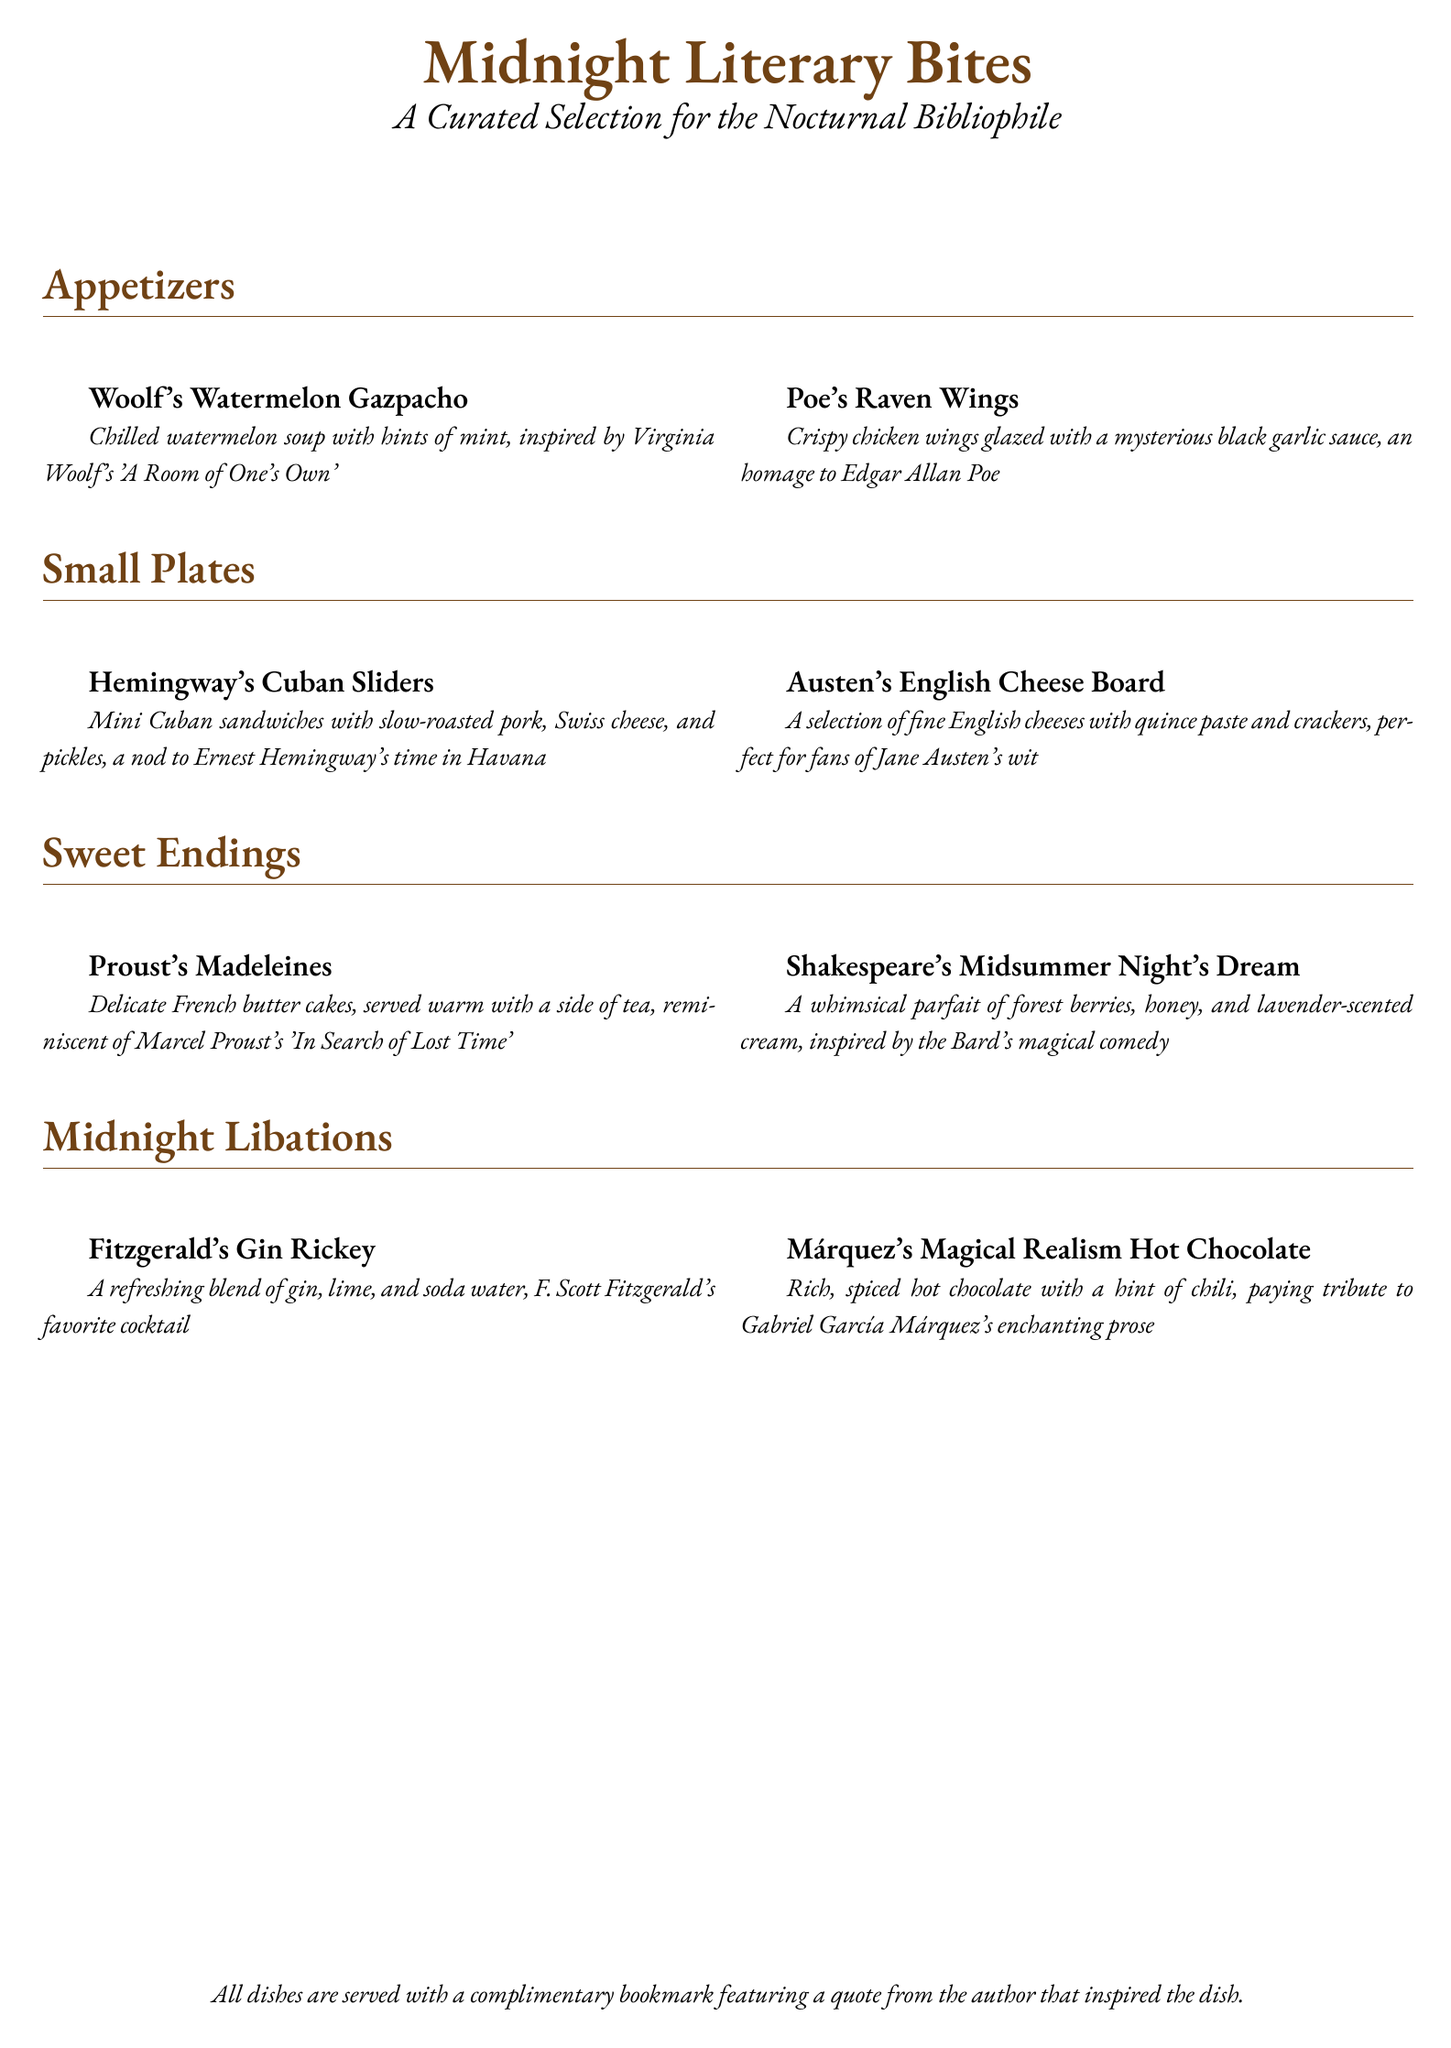What inspired Woolf's Watermelon Gazpacho? The gazpacho is inspired by Virginia Woolf's 'A Room of One's Own'.
Answer: 'A Room of One's Own' What dishes are included in the Sweet Endings section? The Sweet Endings section features Proust's Madeleines and Shakespeare's Midsummer Night's Dream.
Answer: Proust's Madeleines, Shakespeare's Midsummer Night's Dream Which author is associated with the drink Fitzgerald's Gin Rickey? The drink is associated with F. Scott Fitzgerald.
Answer: F. Scott Fitzgerald How many small plates are listed on the menu? There are two small plates listed on the menu: Hemingway's Cuban Sliders and Austen's English Cheese Board.
Answer: 2 What is served with all dishes? All dishes are served with a complimentary bookmark featuring a quote from the author that inspired the dish.
Answer: A complimentary bookmark What type of cuisine is Hemingway's Cuban Sliders? The sliders are a type of mini Cuban sandwiches.
Answer: Mini Cuban sandwiches Which dish pays tribute to Gabriel García Márquez? Márquez's Magical Realism Hot Chocolate pays tribute to Gabriel García Márquez.
Answer: Márquez's Magical Realism Hot Chocolate What is the theme of the Midnight Literary Bites menu? The theme is a curated selection for the nocturnal bibliophile.
Answer: Nocturnal bibliophile 